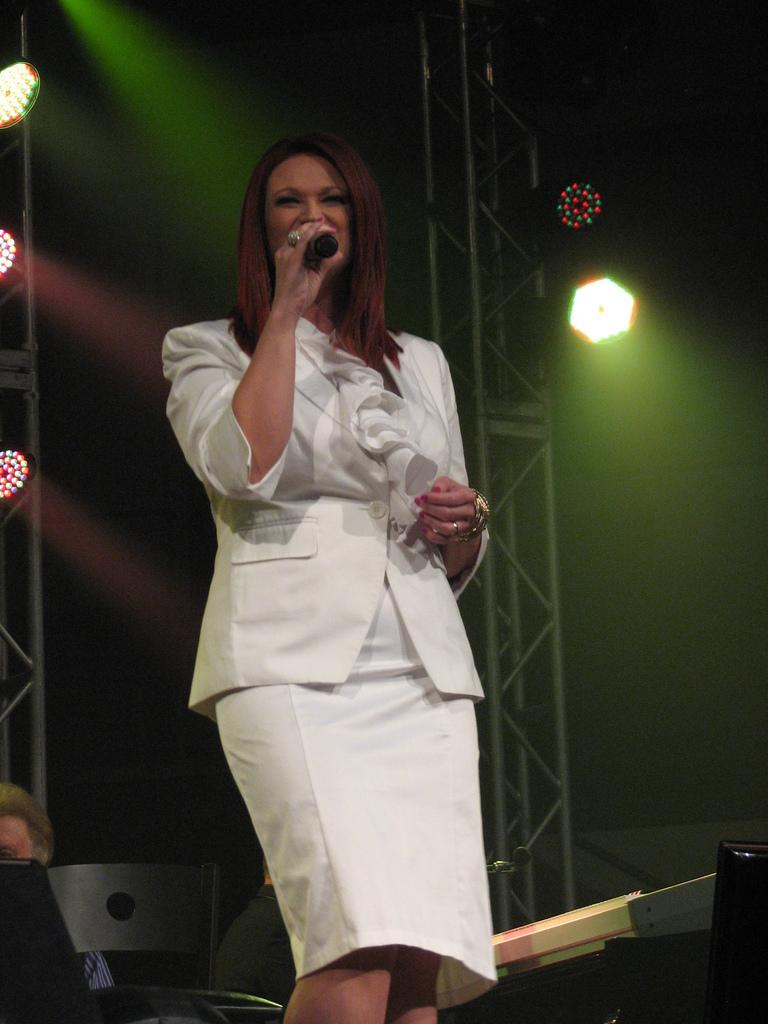What is the lady in the image doing? The lady is standing in the center of the image and holding a mic. What can be seen in the background of the image? There are lights and rods visible in the background of the image. What object is at the bottom of the image? There is a chair at the bottom of the image. How many horses are visible in the image? There are no horses present in the image. What type of approval is the lady seeking in the image? The image does not provide any information about the lady seeking approval. 